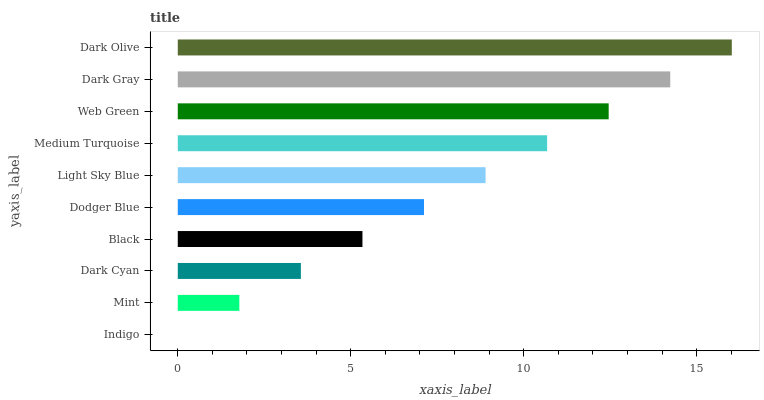Is Indigo the minimum?
Answer yes or no. Yes. Is Dark Olive the maximum?
Answer yes or no. Yes. Is Mint the minimum?
Answer yes or no. No. Is Mint the maximum?
Answer yes or no. No. Is Mint greater than Indigo?
Answer yes or no. Yes. Is Indigo less than Mint?
Answer yes or no. Yes. Is Indigo greater than Mint?
Answer yes or no. No. Is Mint less than Indigo?
Answer yes or no. No. Is Light Sky Blue the high median?
Answer yes or no. Yes. Is Dodger Blue the low median?
Answer yes or no. Yes. Is Black the high median?
Answer yes or no. No. Is Web Green the low median?
Answer yes or no. No. 